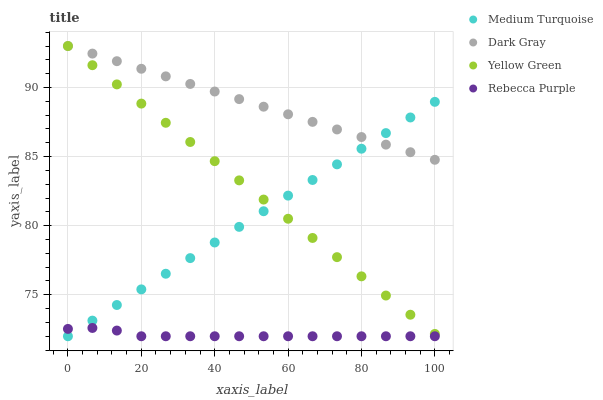Does Rebecca Purple have the minimum area under the curve?
Answer yes or no. Yes. Does Dark Gray have the maximum area under the curve?
Answer yes or no. Yes. Does Yellow Green have the minimum area under the curve?
Answer yes or no. No. Does Yellow Green have the maximum area under the curve?
Answer yes or no. No. Is Yellow Green the smoothest?
Answer yes or no. Yes. Is Rebecca Purple the roughest?
Answer yes or no. Yes. Is Medium Turquoise the smoothest?
Answer yes or no. No. Is Medium Turquoise the roughest?
Answer yes or no. No. Does Medium Turquoise have the lowest value?
Answer yes or no. Yes. Does Yellow Green have the lowest value?
Answer yes or no. No. Does Yellow Green have the highest value?
Answer yes or no. Yes. Does Medium Turquoise have the highest value?
Answer yes or no. No. Is Rebecca Purple less than Yellow Green?
Answer yes or no. Yes. Is Yellow Green greater than Rebecca Purple?
Answer yes or no. Yes. Does Rebecca Purple intersect Medium Turquoise?
Answer yes or no. Yes. Is Rebecca Purple less than Medium Turquoise?
Answer yes or no. No. Is Rebecca Purple greater than Medium Turquoise?
Answer yes or no. No. Does Rebecca Purple intersect Yellow Green?
Answer yes or no. No. 